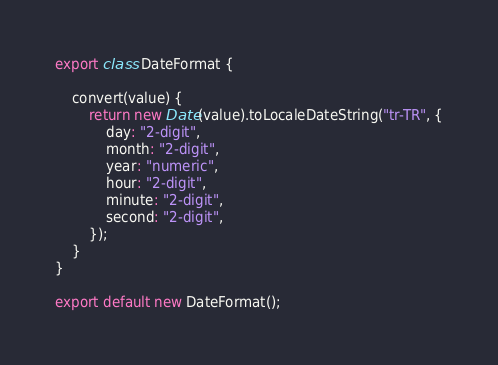Convert code to text. <code><loc_0><loc_0><loc_500><loc_500><_JavaScript_>export class DateFormat {

    convert(value) {
        return new Date(value).toLocaleDateString("tr-TR", {
            day: "2-digit",
            month: "2-digit",
            year: "numeric",
            hour: "2-digit",
            minute: "2-digit",
            second: "2-digit",
        });
    }
}

export default new DateFormat();</code> 